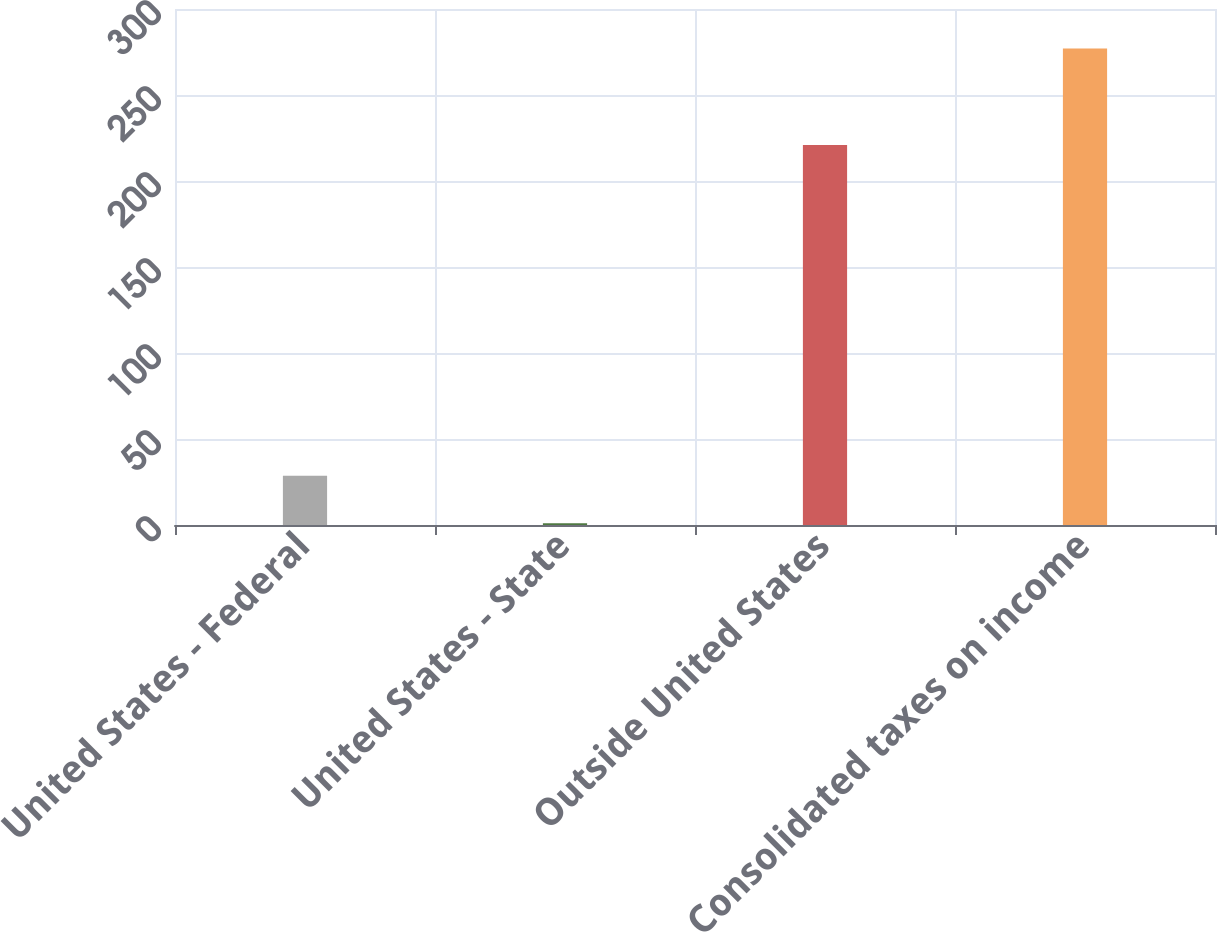Convert chart. <chart><loc_0><loc_0><loc_500><loc_500><bar_chart><fcel>United States - Federal<fcel>United States - State<fcel>Outside United States<fcel>Consolidated taxes on income<nl><fcel>28.6<fcel>1<fcel>221<fcel>277<nl></chart> 